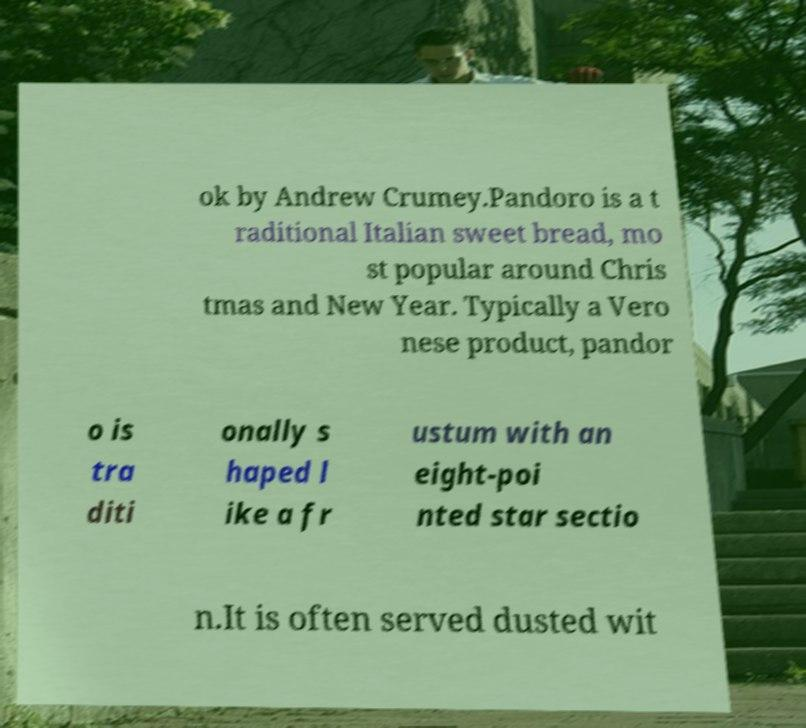Could you extract and type out the text from this image? ok by Andrew Crumey.Pandoro is a t raditional Italian sweet bread, mo st popular around Chris tmas and New Year. Typically a Vero nese product, pandor o is tra diti onally s haped l ike a fr ustum with an eight-poi nted star sectio n.It is often served dusted wit 